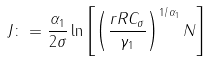<formula> <loc_0><loc_0><loc_500><loc_500>J \colon = \frac { \alpha _ { 1 } } { 2 \sigma } \ln \left [ \left ( \frac { r R C _ { \sigma } } { \gamma _ { 1 } } \right ) ^ { 1 / \alpha _ { 1 } } N \right ]</formula> 